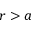<formula> <loc_0><loc_0><loc_500><loc_500>r > a</formula> 